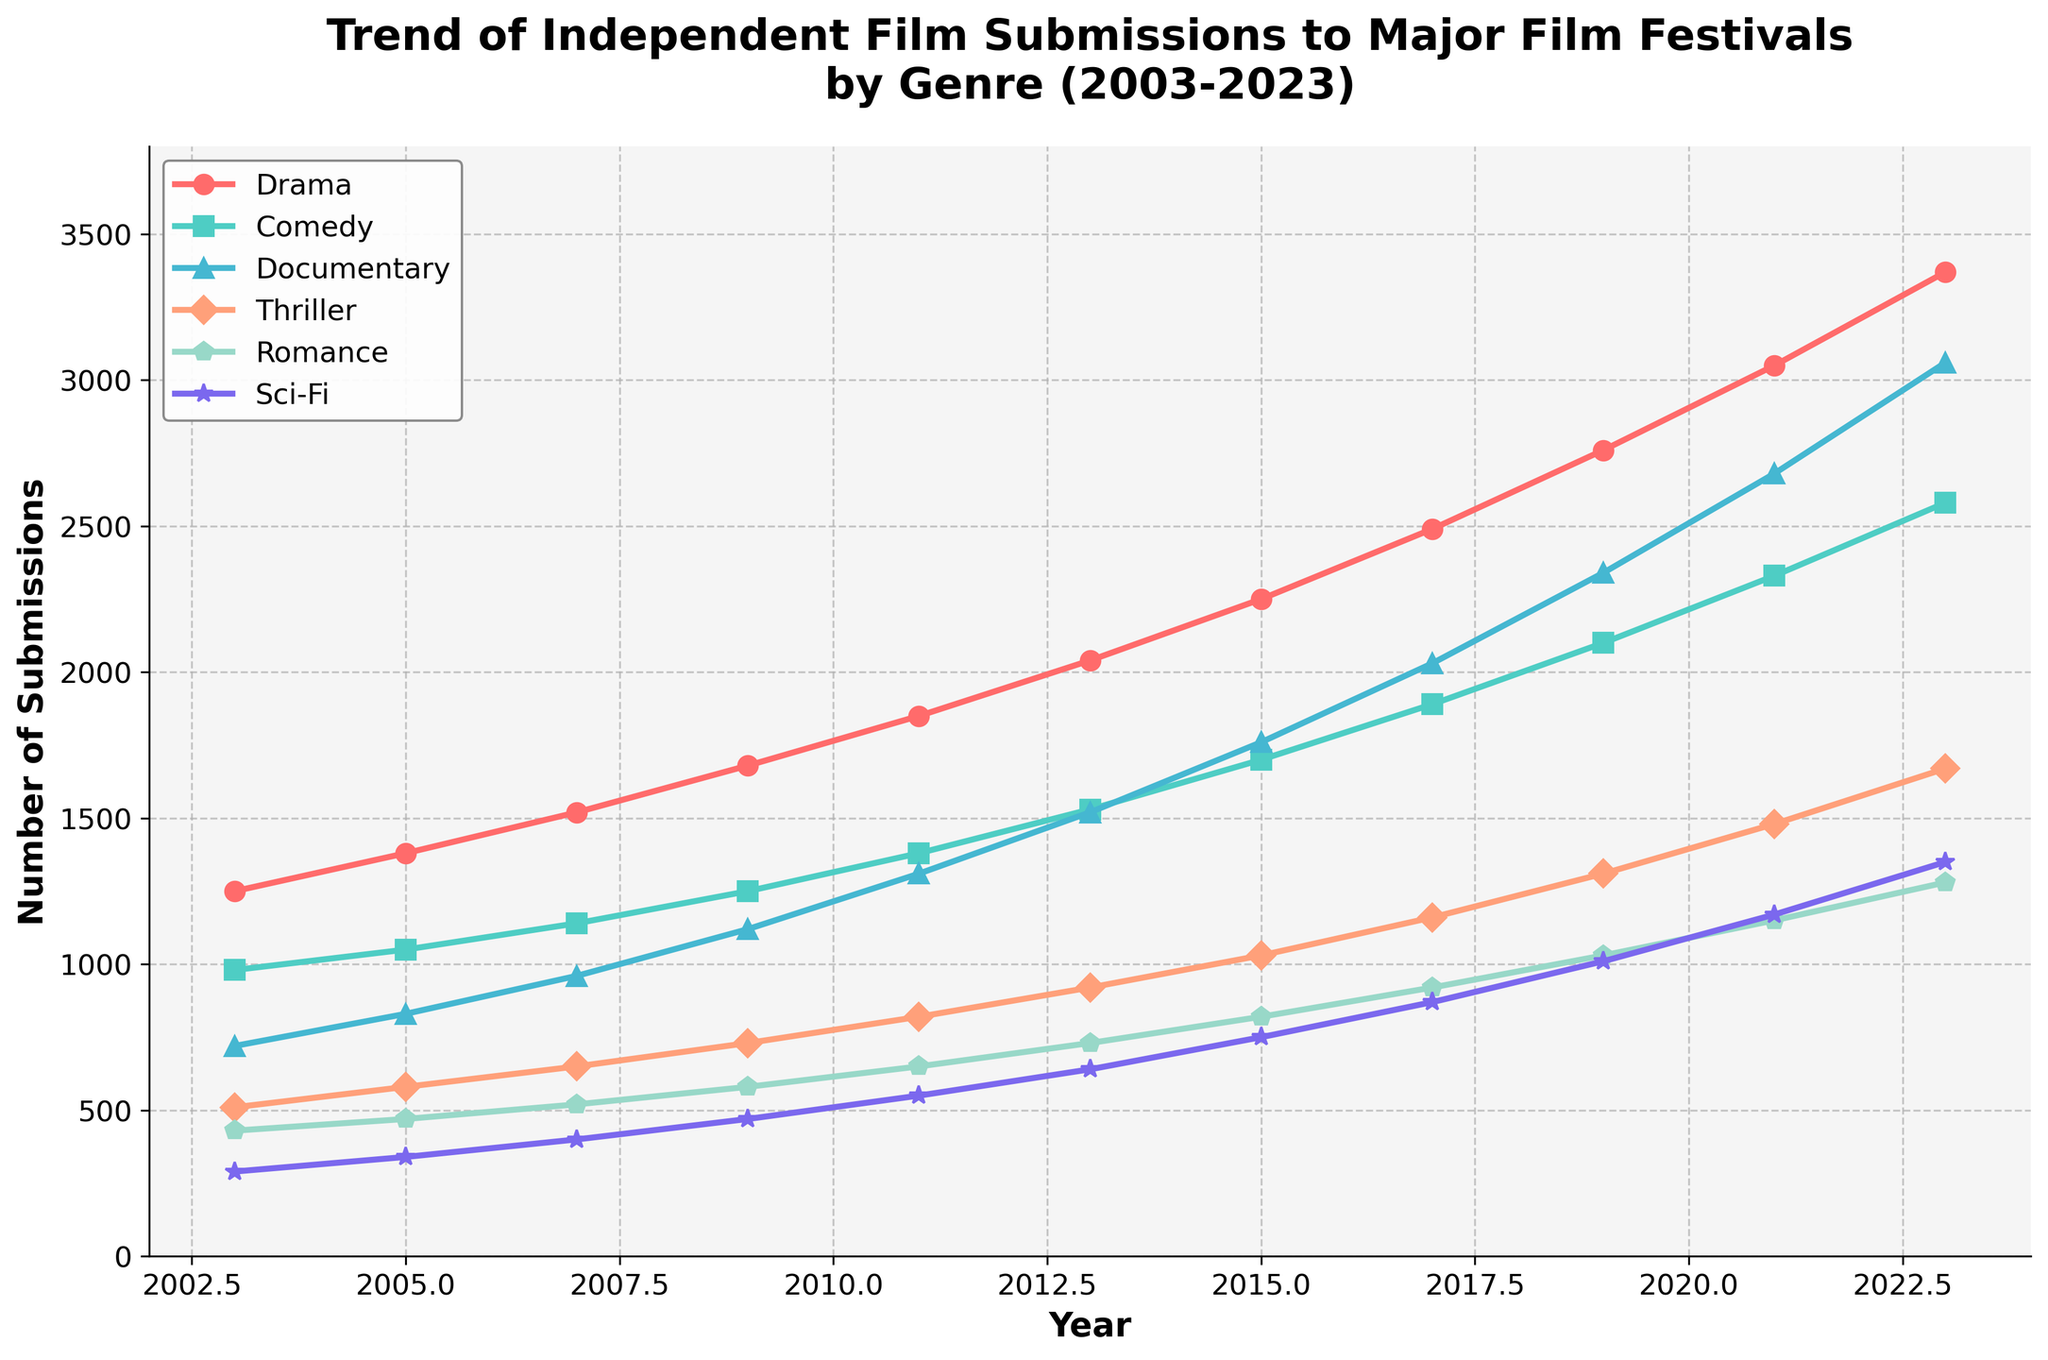What genre had the most submissions in 2023? The genre with the most submissions can be identified by looking at the highest data point in 2023. According to the figure, Drama had the highest submissions.
Answer: Drama How many more Drama films were submitted in 2023 compared to 2003? To find the difference, subtract the 2003 submissions from the 2023 submissions for Drama. 3370 (2023) - 1250 (2003) = 2120
Answer: 2120 Which two genres had similar submission numbers in 2013? By comparing the data points for 2013, we see that Thriller and Romance had submission numbers that appear close. Thriller had 920 submissions and Romance had 730 submissions.
Answer: Thriller and Romance What is the average number of Documentary film submissions from 2003 to 2023? To find the average, add up all the Documentary submissions from 2003 to 2023 and divide by the number of data points (11). (720 + 830 + 960 + 1120 + 1310 + 1520 + 1760 + 2030 + 2340 + 2680 + 3060) / 11 = 1676.36
Answer: 1676.36 Between 2011 and 2017, which genre saw the greatest increase in submissions? By comparing the submission numbers from 2011 and 2017 for each genre, Drama increased by 640, Comedy by 510, Documentary by 720, Thriller by 340, Romance by 270, and Sci-Fi by 320. Documentary had the greatest increase of 720.
Answer: Documentary Which genre had the least submissions in 2007? By looking at the 2007 data points, Sci-Fi had the least submissions at 400.
Answer: Sci-Fi In which year did Comedy submissions first surpass 2000? Reviewing the years in sequence, Comedy submissions surpass 2000 in 2019.
Answer: 2019 What is the total number of Thriller submissions from 2003 to 2023? Sum all the Thriller submission numbers from 2003 to 2023. 510 + 580 + 650 + 730 + 820 + 920 + 1030 + 1160 + 1310 + 1480 + 1670 = 10860
Answer: 10860 Compare the trends of Drama and Sci-Fi submissions over the 20 years. Which had a steeper increase? Drama starts at 1250 in 2003 and ends at 3370 in 2023, while Sci-Fi starts at 290 in 2003 and ends at 1350 in 2023. Calculating the increase per year, we see Drama had (3370-1250)/20 ≈ 106, while Sci-Fi had (1350-290)/20 ≈ 53.1. Drama had a steeper increase.
Answer: Drama 